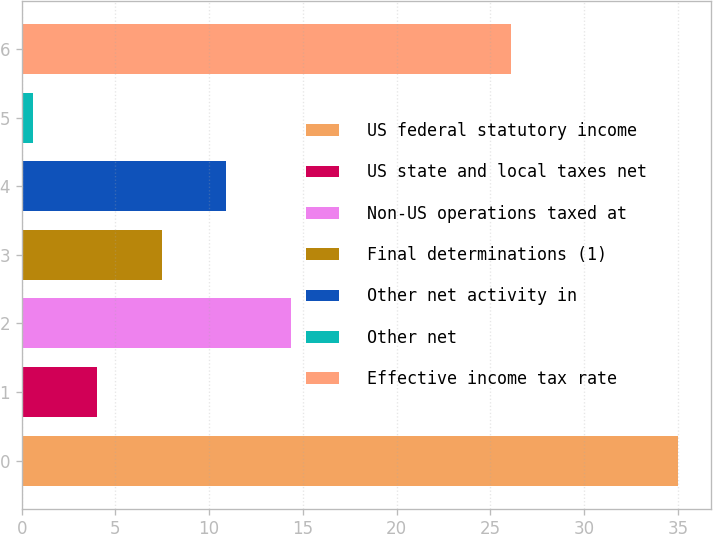Convert chart. <chart><loc_0><loc_0><loc_500><loc_500><bar_chart><fcel>US federal statutory income<fcel>US state and local taxes net<fcel>Non-US operations taxed at<fcel>Final determinations (1)<fcel>Other net activity in<fcel>Other net<fcel>Effective income tax rate<nl><fcel>35<fcel>4.04<fcel>14.36<fcel>7.48<fcel>10.92<fcel>0.6<fcel>26.1<nl></chart> 